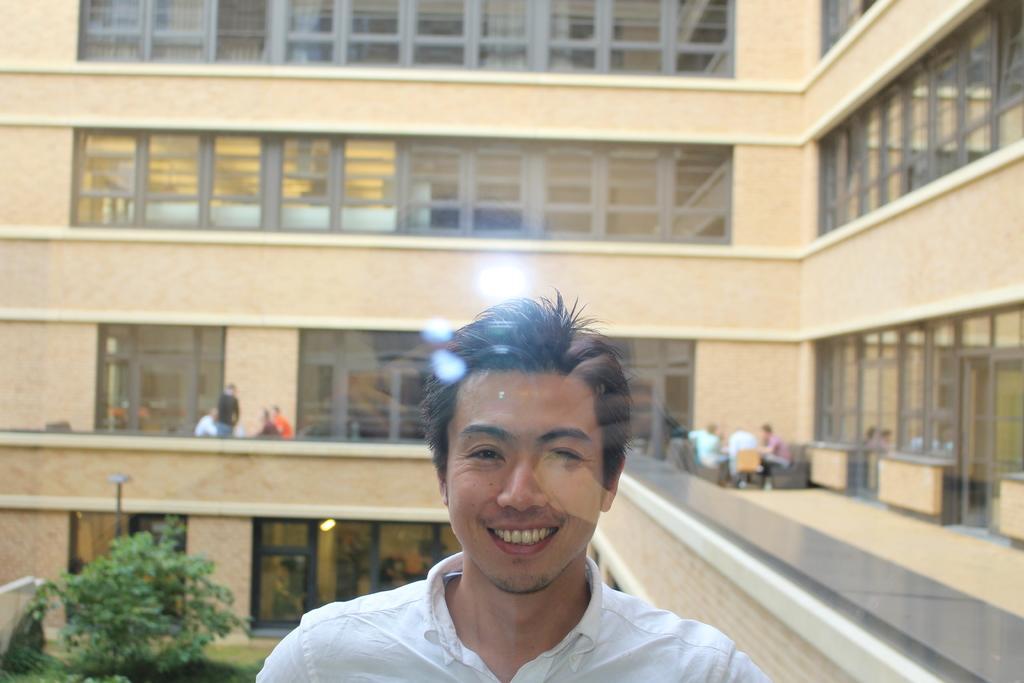Please provide a concise description of this image. In this picture we can see a man smiling and at the back of him we can see a building with windows, curtains, tree, grass, pole and some people sitting on chairs and a person standing. 